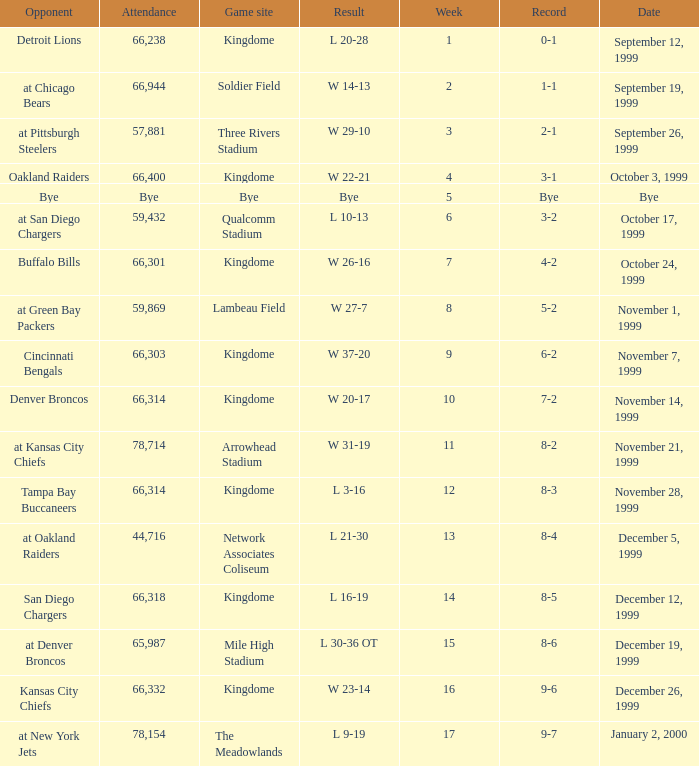For the game that was played on week 2, what is the record? 1-1. 